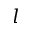Convert formula to latex. <formula><loc_0><loc_0><loc_500><loc_500>l</formula> 